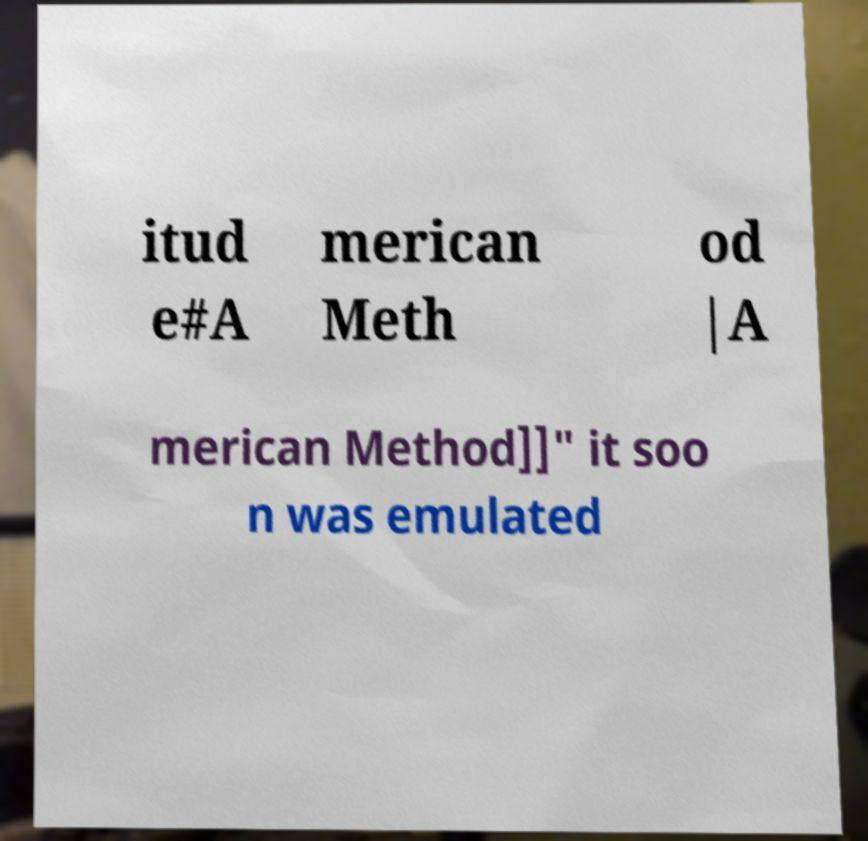Could you assist in decoding the text presented in this image and type it out clearly? itud e#A merican Meth od |A merican Method]]" it soo n was emulated 